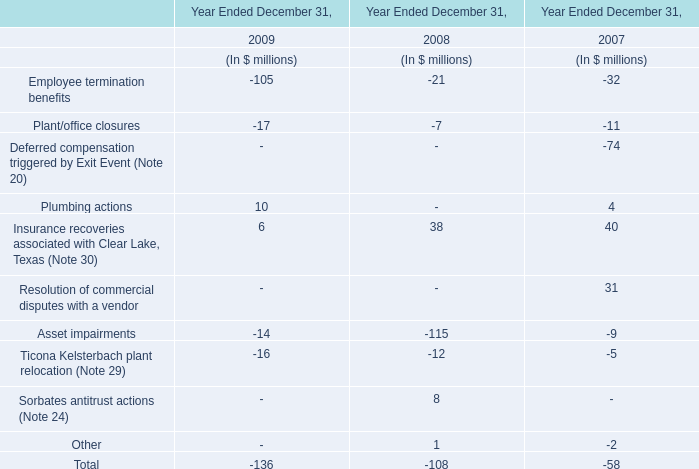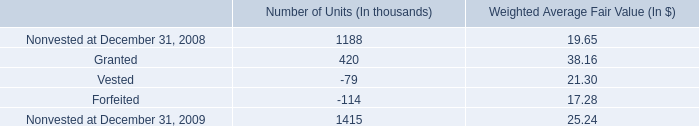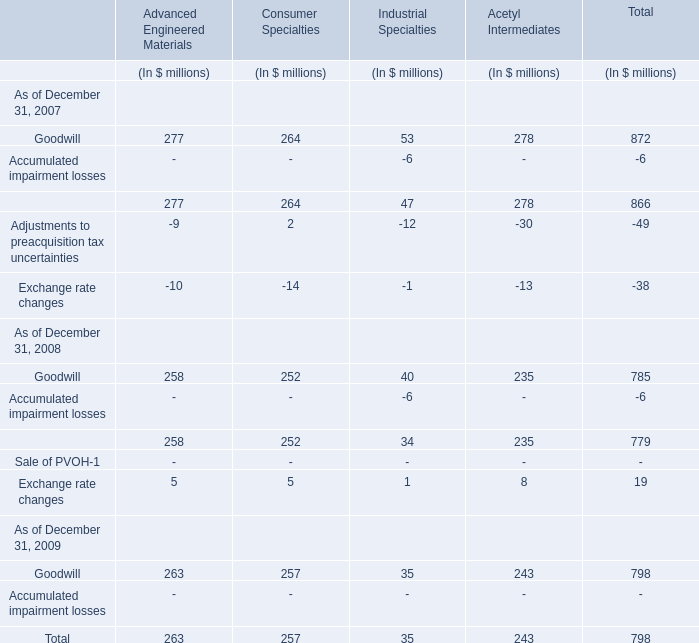what is the highest total amount of goodwill in 2017? (in million) 
Computations: (((277 + 264) + 53) + 278)
Answer: 872.0. 